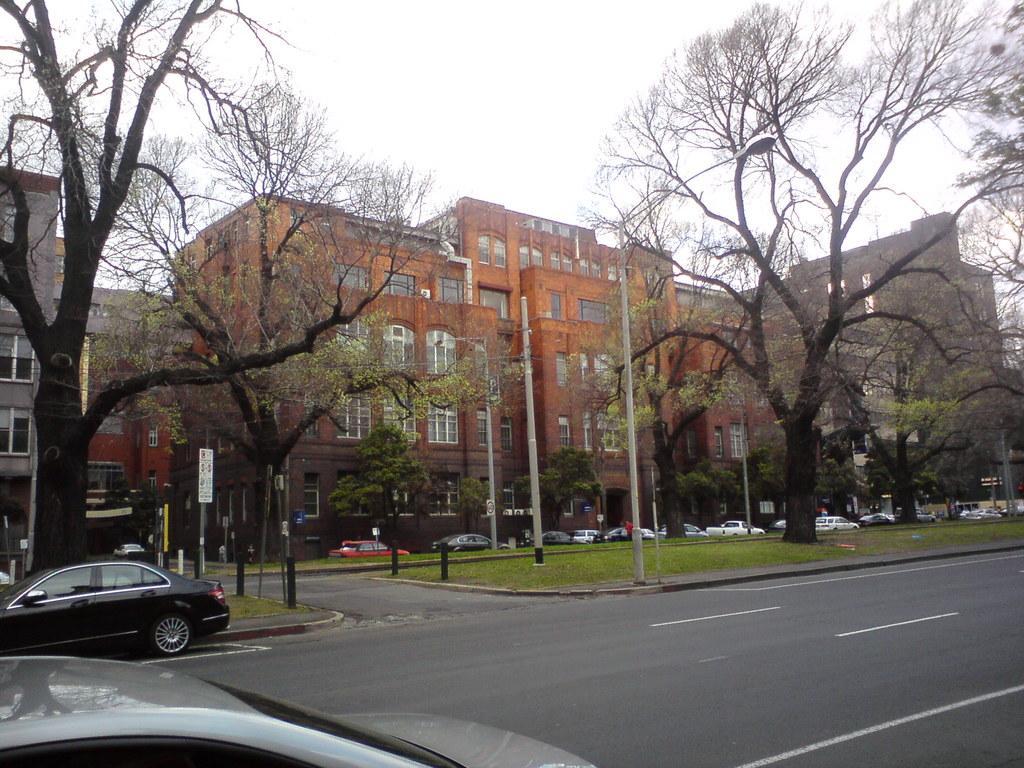What type of structures can be seen in the image? There are buildings in the image. What is located in front of the buildings? Trees are present in front of the buildings. What else can be seen in the image besides buildings and trees? There are poles, parked vehicles, and moving vehicles on the road in the image. What is visible in the background of the image? The sky is visible in the background of the image. How many women are walking on the ground in the image? There are no women or ground present in the image. What type of minister is depicted in the image? There is no minister present in the image. 